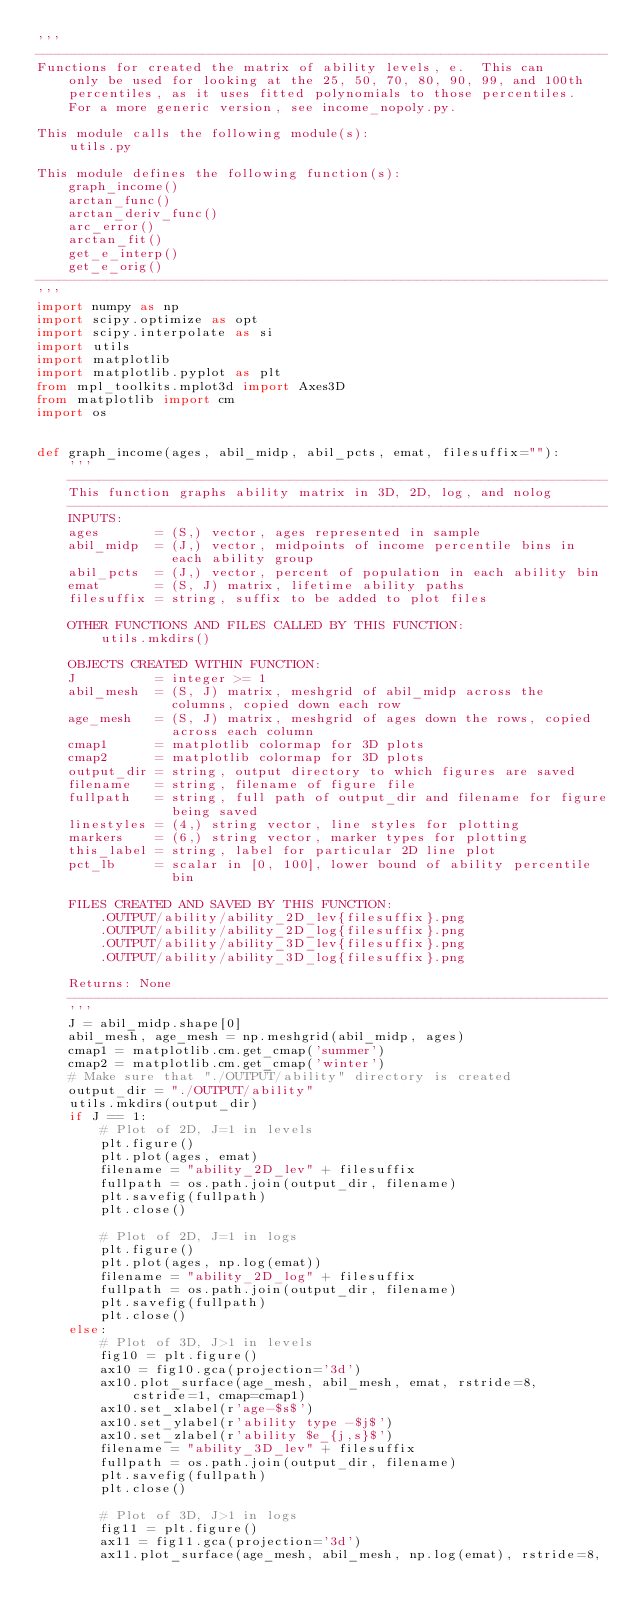<code> <loc_0><loc_0><loc_500><loc_500><_Python_>'''
------------------------------------------------------------------------
Functions for created the matrix of ability levels, e.  This can
    only be used for looking at the 25, 50, 70, 80, 90, 99, and 100th
    percentiles, as it uses fitted polynomials to those percentiles.
    For a more generic version, see income_nopoly.py.

This module calls the following module(s):
    utils.py

This module defines the following function(s):
    graph_income()
    arctan_func()
    arctan_deriv_func()
    arc_error()
    arctan_fit()
    get_e_interp()
    get_e_orig()
------------------------------------------------------------------------
'''
import numpy as np
import scipy.optimize as opt
import scipy.interpolate as si
import utils
import matplotlib
import matplotlib.pyplot as plt
from mpl_toolkits.mplot3d import Axes3D
from matplotlib import cm
import os


def graph_income(ages, abil_midp, abil_pcts, emat, filesuffix=""):
    '''
    --------------------------------------------------------------------
    This function graphs ability matrix in 3D, 2D, log, and nolog
    --------------------------------------------------------------------
    INPUTS:
    ages       = (S,) vector, ages represented in sample
    abil_midp  = (J,) vector, midpoints of income percentile bins in
                 each ability group
    abil_pcts  = (J,) vector, percent of population in each ability bin
    emat       = (S, J) matrix, lifetime ability paths
    filesuffix = string, suffix to be added to plot files

    OTHER FUNCTIONS AND FILES CALLED BY THIS FUNCTION:
        utils.mkdirs()

    OBJECTS CREATED WITHIN FUNCTION:
    J          = integer >= 1
    abil_mesh  = (S, J) matrix, meshgrid of abil_midp across the
                 columns, copied down each row
    age_mesh   = (S, J) matrix, meshgrid of ages down the rows, copied
                 across each column
    cmap1      = matplotlib colormap for 3D plots
    cmap2      = matplotlib colormap for 3D plots
    output_dir = string, output directory to which figures are saved
    filename   = string, filename of figure file
    fullpath   = string, full path of output_dir and filename for figure
                 being saved
    linestyles = (4,) string vector, line styles for plotting
    markers    = (6,) string vector, marker types for plotting
    this_label = string, label for particular 2D line plot
    pct_lb     = scalar in [0, 100], lower bound of ability percentile
                 bin

    FILES CREATED AND SAVED BY THIS FUNCTION:
        .OUTPUT/ability/ability_2D_lev{filesuffix}.png
        .OUTPUT/ability/ability_2D_log{filesuffix}.png
        .OUTPUT/ability/ability_3D_lev{filesuffix}.png
        .OUTPUT/ability/ability_3D_log{filesuffix}.png

    Returns: None
    --------------------------------------------------------------------
    '''
    J = abil_midp.shape[0]
    abil_mesh, age_mesh = np.meshgrid(abil_midp, ages)
    cmap1 = matplotlib.cm.get_cmap('summer')
    cmap2 = matplotlib.cm.get_cmap('winter')
    # Make sure that "./OUTPUT/ability" directory is created
    output_dir = "./OUTPUT/ability"
    utils.mkdirs(output_dir)
    if J == 1:
        # Plot of 2D, J=1 in levels
        plt.figure()
        plt.plot(ages, emat)
        filename = "ability_2D_lev" + filesuffix
        fullpath = os.path.join(output_dir, filename)
        plt.savefig(fullpath)
        plt.close()

        # Plot of 2D, J=1 in logs
        plt.figure()
        plt.plot(ages, np.log(emat))
        filename = "ability_2D_log" + filesuffix
        fullpath = os.path.join(output_dir, filename)
        plt.savefig(fullpath)
        plt.close()
    else:
        # Plot of 3D, J>1 in levels
        fig10 = plt.figure()
        ax10 = fig10.gca(projection='3d')
        ax10.plot_surface(age_mesh, abil_mesh, emat, rstride=8,
            cstride=1, cmap=cmap1)
        ax10.set_xlabel(r'age-$s$')
        ax10.set_ylabel(r'ability type -$j$')
        ax10.set_zlabel(r'ability $e_{j,s}$')
        filename = "ability_3D_lev" + filesuffix
        fullpath = os.path.join(output_dir, filename)
        plt.savefig(fullpath)
        plt.close()

        # Plot of 3D, J>1 in logs
        fig11 = plt.figure()
        ax11 = fig11.gca(projection='3d')
        ax11.plot_surface(age_mesh, abil_mesh, np.log(emat), rstride=8,</code> 